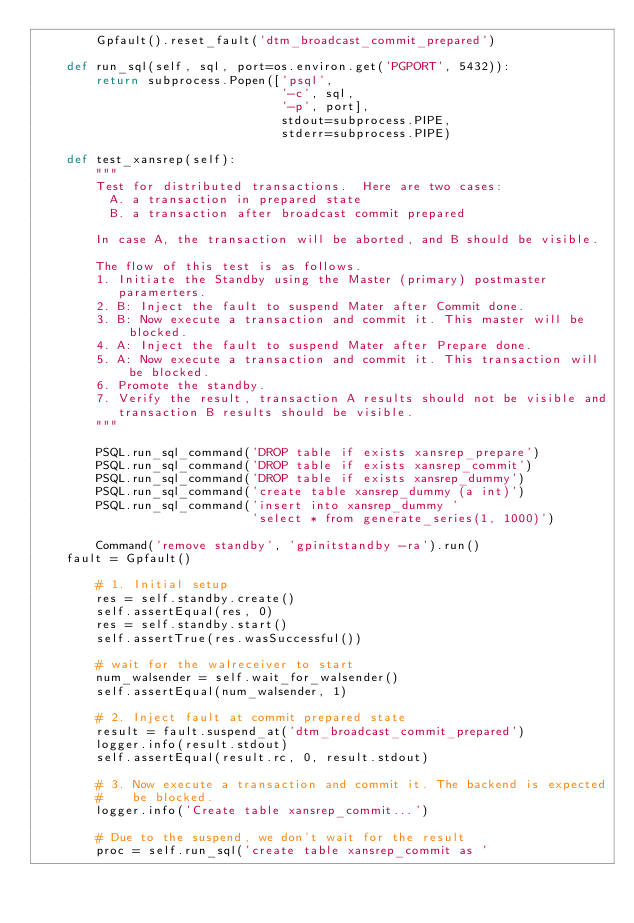Convert code to text. <code><loc_0><loc_0><loc_500><loc_500><_Python_>        Gpfault().reset_fault('dtm_broadcast_commit_prepared')

    def run_sql(self, sql, port=os.environ.get('PGPORT', 5432)):
        return subprocess.Popen(['psql',
                                 '-c', sql,
                                 '-p', port],
                                 stdout=subprocess.PIPE,
                                 stderr=subprocess.PIPE)

    def test_xansrep(self):
        """
        Test for distributed transactions.  Here are two cases:
          A. a transaction in prepared state
          B. a transaction after broadcast commit prepared

        In case A, the transaction will be aborted, and B should be visible.

        The flow of this test is as follows.
        1. Initiate the Standby using the Master (primary) postmaster
           paramerters.
        2. B: Inject the fault to suspend Mater after Commit done.
        3. B: Now execute a transaction and commit it. This master will be blocked.
        4. A: Inject the fault to suspend Mater after Prepare done.
        5. A: Now execute a transaction and commit it. This transaction will be blocked.
        6. Promote the standby.
        7. Verify the result, transaction A results should not be visible and
           transaction B results should be visible.
        """

        PSQL.run_sql_command('DROP table if exists xansrep_prepare')
        PSQL.run_sql_command('DROP table if exists xansrep_commit')
        PSQL.run_sql_command('DROP table if exists xansrep_dummy')
        PSQL.run_sql_command('create table xansrep_dummy (a int)')
        PSQL.run_sql_command('insert into xansrep_dummy '
                             'select * from generate_series(1, 1000)')

        Command('remove standby', 'gpinitstandby -ra').run()
	fault = Gpfault()

        # 1. Initial setup
        res = self.standby.create()
        self.assertEqual(res, 0)
        res = self.standby.start()
        self.assertTrue(res.wasSuccessful())

        # wait for the walreceiver to start
        num_walsender = self.wait_for_walsender()
        self.assertEqual(num_walsender, 1)

        # 2. Inject fault at commit prepared state
        result = fault.suspend_at('dtm_broadcast_commit_prepared')
        logger.info(result.stdout)
        self.assertEqual(result.rc, 0, result.stdout)

        # 3. Now execute a transaction and commit it. The backend is expected
        #    be blocked.
        logger.info('Create table xansrep_commit...')

        # Due to the suspend, we don't wait for the result
        proc = self.run_sql('create table xansrep_commit as '</code> 